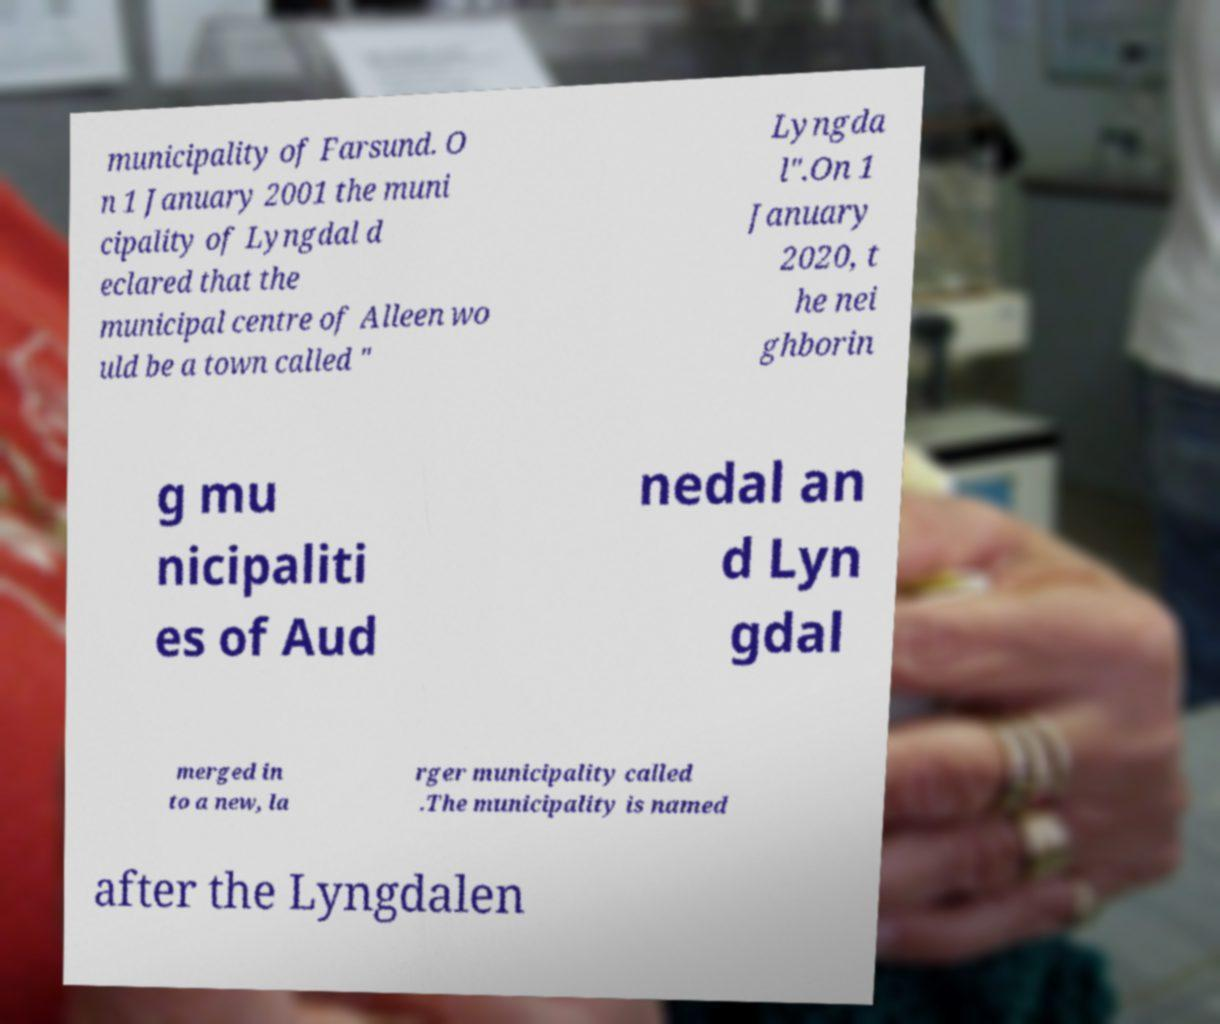I need the written content from this picture converted into text. Can you do that? municipality of Farsund. O n 1 January 2001 the muni cipality of Lyngdal d eclared that the municipal centre of Alleen wo uld be a town called " Lyngda l".On 1 January 2020, t he nei ghborin g mu nicipaliti es of Aud nedal an d Lyn gdal merged in to a new, la rger municipality called .The municipality is named after the Lyngdalen 